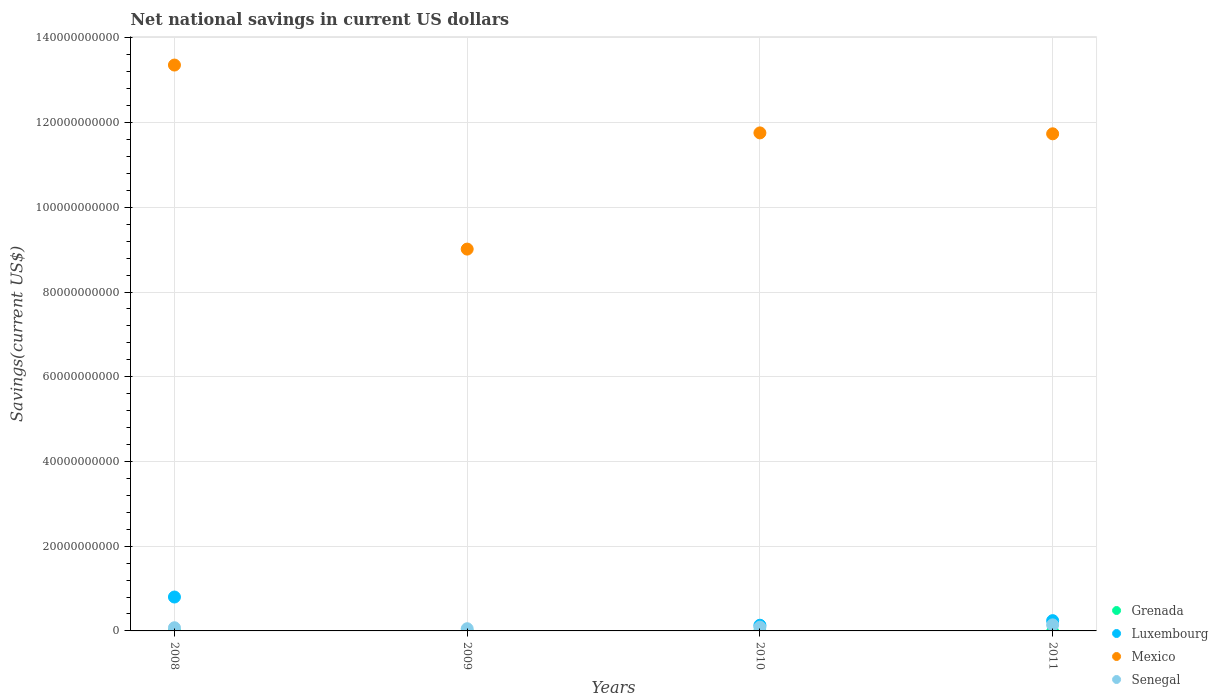How many different coloured dotlines are there?
Offer a terse response. 3. What is the net national savings in Senegal in 2008?
Your response must be concise. 7.47e+08. Across all years, what is the maximum net national savings in Senegal?
Keep it short and to the point. 1.43e+09. Across all years, what is the minimum net national savings in Luxembourg?
Provide a short and direct response. 0. In which year was the net national savings in Mexico maximum?
Offer a very short reply. 2008. What is the total net national savings in Luxembourg in the graph?
Give a very brief answer. 1.18e+1. What is the difference between the net national savings in Senegal in 2008 and that in 2009?
Provide a short and direct response. 2.30e+08. What is the difference between the net national savings in Senegal in 2011 and the net national savings in Grenada in 2009?
Make the answer very short. 1.43e+09. What is the average net national savings in Grenada per year?
Provide a succinct answer. 0. In the year 2008, what is the difference between the net national savings in Senegal and net national savings in Luxembourg?
Make the answer very short. -7.26e+09. In how many years, is the net national savings in Luxembourg greater than 52000000000 US$?
Ensure brevity in your answer.  0. What is the ratio of the net national savings in Mexico in 2009 to that in 2010?
Ensure brevity in your answer.  0.77. Is the difference between the net national savings in Senegal in 2008 and 2010 greater than the difference between the net national savings in Luxembourg in 2008 and 2010?
Ensure brevity in your answer.  No. What is the difference between the highest and the second highest net national savings in Mexico?
Ensure brevity in your answer.  1.60e+1. What is the difference between the highest and the lowest net national savings in Senegal?
Provide a succinct answer. 9.11e+08. In how many years, is the net national savings in Senegal greater than the average net national savings in Senegal taken over all years?
Your response must be concise. 1. Is the sum of the net national savings in Senegal in 2009 and 2011 greater than the maximum net national savings in Grenada across all years?
Offer a terse response. Yes. Is it the case that in every year, the sum of the net national savings in Luxembourg and net national savings in Senegal  is greater than the net national savings in Grenada?
Give a very brief answer. Yes. Does the net national savings in Mexico monotonically increase over the years?
Make the answer very short. No. Is the net national savings in Mexico strictly greater than the net national savings in Senegal over the years?
Keep it short and to the point. Yes. How many dotlines are there?
Your answer should be compact. 3. How many years are there in the graph?
Offer a very short reply. 4. Are the values on the major ticks of Y-axis written in scientific E-notation?
Your response must be concise. No. How are the legend labels stacked?
Your response must be concise. Vertical. What is the title of the graph?
Offer a terse response. Net national savings in current US dollars. What is the label or title of the Y-axis?
Provide a short and direct response. Savings(current US$). What is the Savings(current US$) of Grenada in 2008?
Offer a very short reply. 0. What is the Savings(current US$) in Luxembourg in 2008?
Ensure brevity in your answer.  8.00e+09. What is the Savings(current US$) of Mexico in 2008?
Your response must be concise. 1.34e+11. What is the Savings(current US$) in Senegal in 2008?
Give a very brief answer. 7.47e+08. What is the Savings(current US$) of Mexico in 2009?
Offer a terse response. 9.01e+1. What is the Savings(current US$) in Senegal in 2009?
Offer a very short reply. 5.17e+08. What is the Savings(current US$) of Luxembourg in 2010?
Make the answer very short. 1.34e+09. What is the Savings(current US$) of Mexico in 2010?
Offer a terse response. 1.18e+11. What is the Savings(current US$) of Senegal in 2010?
Ensure brevity in your answer.  8.91e+08. What is the Savings(current US$) in Grenada in 2011?
Ensure brevity in your answer.  0. What is the Savings(current US$) in Luxembourg in 2011?
Provide a short and direct response. 2.42e+09. What is the Savings(current US$) of Mexico in 2011?
Offer a very short reply. 1.17e+11. What is the Savings(current US$) in Senegal in 2011?
Your response must be concise. 1.43e+09. Across all years, what is the maximum Savings(current US$) of Luxembourg?
Keep it short and to the point. 8.00e+09. Across all years, what is the maximum Savings(current US$) in Mexico?
Provide a short and direct response. 1.34e+11. Across all years, what is the maximum Savings(current US$) of Senegal?
Offer a terse response. 1.43e+09. Across all years, what is the minimum Savings(current US$) of Luxembourg?
Provide a succinct answer. 0. Across all years, what is the minimum Savings(current US$) in Mexico?
Give a very brief answer. 9.01e+1. Across all years, what is the minimum Savings(current US$) of Senegal?
Provide a short and direct response. 5.17e+08. What is the total Savings(current US$) in Grenada in the graph?
Offer a terse response. 0. What is the total Savings(current US$) in Luxembourg in the graph?
Offer a very short reply. 1.18e+1. What is the total Savings(current US$) of Mexico in the graph?
Your response must be concise. 4.59e+11. What is the total Savings(current US$) in Senegal in the graph?
Offer a very short reply. 3.58e+09. What is the difference between the Savings(current US$) in Mexico in 2008 and that in 2009?
Offer a terse response. 4.34e+1. What is the difference between the Savings(current US$) of Senegal in 2008 and that in 2009?
Your response must be concise. 2.30e+08. What is the difference between the Savings(current US$) of Luxembourg in 2008 and that in 2010?
Ensure brevity in your answer.  6.66e+09. What is the difference between the Savings(current US$) in Mexico in 2008 and that in 2010?
Make the answer very short. 1.60e+1. What is the difference between the Savings(current US$) of Senegal in 2008 and that in 2010?
Keep it short and to the point. -1.44e+08. What is the difference between the Savings(current US$) of Luxembourg in 2008 and that in 2011?
Offer a terse response. 5.58e+09. What is the difference between the Savings(current US$) of Mexico in 2008 and that in 2011?
Your answer should be compact. 1.62e+1. What is the difference between the Savings(current US$) in Senegal in 2008 and that in 2011?
Make the answer very short. -6.81e+08. What is the difference between the Savings(current US$) of Mexico in 2009 and that in 2010?
Give a very brief answer. -2.74e+1. What is the difference between the Savings(current US$) in Senegal in 2009 and that in 2010?
Offer a terse response. -3.74e+08. What is the difference between the Savings(current US$) in Mexico in 2009 and that in 2011?
Provide a short and direct response. -2.72e+1. What is the difference between the Savings(current US$) in Senegal in 2009 and that in 2011?
Your response must be concise. -9.11e+08. What is the difference between the Savings(current US$) of Luxembourg in 2010 and that in 2011?
Your response must be concise. -1.08e+09. What is the difference between the Savings(current US$) of Mexico in 2010 and that in 2011?
Ensure brevity in your answer.  2.15e+08. What is the difference between the Savings(current US$) in Senegal in 2010 and that in 2011?
Offer a terse response. -5.37e+08. What is the difference between the Savings(current US$) of Luxembourg in 2008 and the Savings(current US$) of Mexico in 2009?
Ensure brevity in your answer.  -8.21e+1. What is the difference between the Savings(current US$) in Luxembourg in 2008 and the Savings(current US$) in Senegal in 2009?
Your answer should be compact. 7.49e+09. What is the difference between the Savings(current US$) of Mexico in 2008 and the Savings(current US$) of Senegal in 2009?
Provide a short and direct response. 1.33e+11. What is the difference between the Savings(current US$) in Luxembourg in 2008 and the Savings(current US$) in Mexico in 2010?
Offer a terse response. -1.10e+11. What is the difference between the Savings(current US$) of Luxembourg in 2008 and the Savings(current US$) of Senegal in 2010?
Your answer should be compact. 7.11e+09. What is the difference between the Savings(current US$) in Mexico in 2008 and the Savings(current US$) in Senegal in 2010?
Make the answer very short. 1.33e+11. What is the difference between the Savings(current US$) of Luxembourg in 2008 and the Savings(current US$) of Mexico in 2011?
Make the answer very short. -1.09e+11. What is the difference between the Savings(current US$) in Luxembourg in 2008 and the Savings(current US$) in Senegal in 2011?
Offer a very short reply. 6.58e+09. What is the difference between the Savings(current US$) in Mexico in 2008 and the Savings(current US$) in Senegal in 2011?
Your answer should be very brief. 1.32e+11. What is the difference between the Savings(current US$) in Mexico in 2009 and the Savings(current US$) in Senegal in 2010?
Give a very brief answer. 8.92e+1. What is the difference between the Savings(current US$) in Mexico in 2009 and the Savings(current US$) in Senegal in 2011?
Make the answer very short. 8.87e+1. What is the difference between the Savings(current US$) in Luxembourg in 2010 and the Savings(current US$) in Mexico in 2011?
Your response must be concise. -1.16e+11. What is the difference between the Savings(current US$) of Luxembourg in 2010 and the Savings(current US$) of Senegal in 2011?
Provide a short and direct response. -8.59e+07. What is the difference between the Savings(current US$) of Mexico in 2010 and the Savings(current US$) of Senegal in 2011?
Keep it short and to the point. 1.16e+11. What is the average Savings(current US$) in Luxembourg per year?
Offer a very short reply. 2.94e+09. What is the average Savings(current US$) of Mexico per year?
Ensure brevity in your answer.  1.15e+11. What is the average Savings(current US$) in Senegal per year?
Provide a succinct answer. 8.96e+08. In the year 2008, what is the difference between the Savings(current US$) of Luxembourg and Savings(current US$) of Mexico?
Your response must be concise. -1.26e+11. In the year 2008, what is the difference between the Savings(current US$) of Luxembourg and Savings(current US$) of Senegal?
Provide a short and direct response. 7.26e+09. In the year 2008, what is the difference between the Savings(current US$) of Mexico and Savings(current US$) of Senegal?
Your answer should be compact. 1.33e+11. In the year 2009, what is the difference between the Savings(current US$) of Mexico and Savings(current US$) of Senegal?
Provide a succinct answer. 8.96e+1. In the year 2010, what is the difference between the Savings(current US$) of Luxembourg and Savings(current US$) of Mexico?
Ensure brevity in your answer.  -1.16e+11. In the year 2010, what is the difference between the Savings(current US$) in Luxembourg and Savings(current US$) in Senegal?
Provide a short and direct response. 4.51e+08. In the year 2010, what is the difference between the Savings(current US$) in Mexico and Savings(current US$) in Senegal?
Give a very brief answer. 1.17e+11. In the year 2011, what is the difference between the Savings(current US$) in Luxembourg and Savings(current US$) in Mexico?
Ensure brevity in your answer.  -1.15e+11. In the year 2011, what is the difference between the Savings(current US$) of Luxembourg and Savings(current US$) of Senegal?
Provide a succinct answer. 9.97e+08. In the year 2011, what is the difference between the Savings(current US$) in Mexico and Savings(current US$) in Senegal?
Your response must be concise. 1.16e+11. What is the ratio of the Savings(current US$) in Mexico in 2008 to that in 2009?
Provide a succinct answer. 1.48. What is the ratio of the Savings(current US$) of Senegal in 2008 to that in 2009?
Your answer should be compact. 1.45. What is the ratio of the Savings(current US$) in Luxembourg in 2008 to that in 2010?
Make the answer very short. 5.96. What is the ratio of the Savings(current US$) in Mexico in 2008 to that in 2010?
Ensure brevity in your answer.  1.14. What is the ratio of the Savings(current US$) of Senegal in 2008 to that in 2010?
Ensure brevity in your answer.  0.84. What is the ratio of the Savings(current US$) in Luxembourg in 2008 to that in 2011?
Make the answer very short. 3.3. What is the ratio of the Savings(current US$) in Mexico in 2008 to that in 2011?
Your answer should be compact. 1.14. What is the ratio of the Savings(current US$) in Senegal in 2008 to that in 2011?
Offer a very short reply. 0.52. What is the ratio of the Savings(current US$) in Mexico in 2009 to that in 2010?
Keep it short and to the point. 0.77. What is the ratio of the Savings(current US$) of Senegal in 2009 to that in 2010?
Give a very brief answer. 0.58. What is the ratio of the Savings(current US$) of Mexico in 2009 to that in 2011?
Provide a short and direct response. 0.77. What is the ratio of the Savings(current US$) in Senegal in 2009 to that in 2011?
Provide a short and direct response. 0.36. What is the ratio of the Savings(current US$) in Luxembourg in 2010 to that in 2011?
Keep it short and to the point. 0.55. What is the ratio of the Savings(current US$) in Mexico in 2010 to that in 2011?
Your answer should be very brief. 1. What is the ratio of the Savings(current US$) of Senegal in 2010 to that in 2011?
Keep it short and to the point. 0.62. What is the difference between the highest and the second highest Savings(current US$) of Luxembourg?
Provide a short and direct response. 5.58e+09. What is the difference between the highest and the second highest Savings(current US$) of Mexico?
Make the answer very short. 1.60e+1. What is the difference between the highest and the second highest Savings(current US$) of Senegal?
Give a very brief answer. 5.37e+08. What is the difference between the highest and the lowest Savings(current US$) in Luxembourg?
Your response must be concise. 8.00e+09. What is the difference between the highest and the lowest Savings(current US$) of Mexico?
Make the answer very short. 4.34e+1. What is the difference between the highest and the lowest Savings(current US$) in Senegal?
Provide a succinct answer. 9.11e+08. 